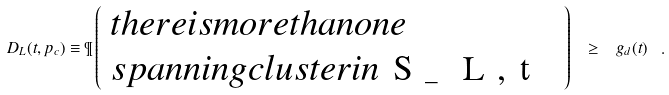Convert formula to latex. <formula><loc_0><loc_0><loc_500><loc_500>D _ { L } ( t , p _ { c } ) \equiv \P \left ( \begin{array} { l } t h e r e i s m o r e t h a n o n e \\ s p a n n i n g c l u s t e r i n $ S _ { L , t } $ \end{array} \right ) \ \geq \ g _ { d } ( t ) \ .</formula> 